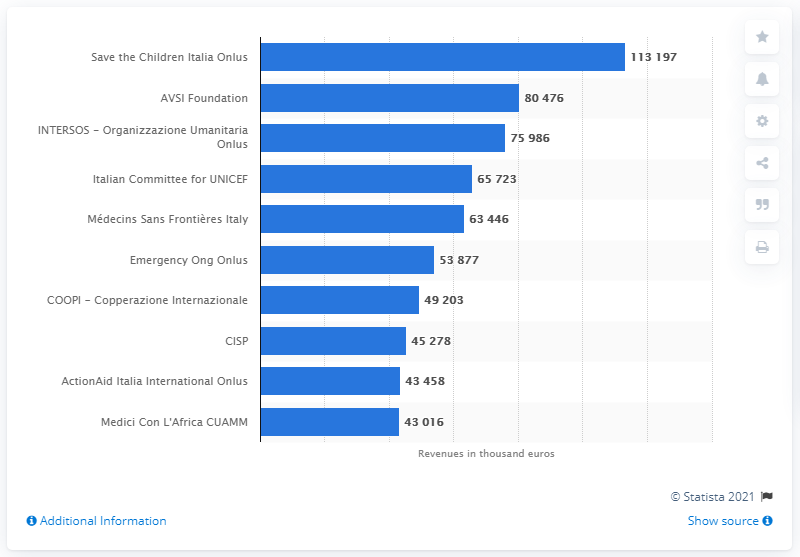List a handful of essential elements in this visual. Save the Children Italia Onlus is the name of the non-governmental organization in Italy. 